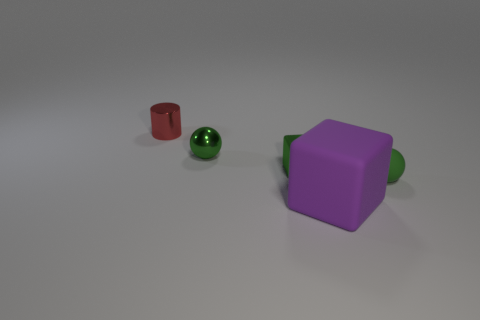Add 5 large purple matte things. How many objects exist? 10 Subtract all cylinders. How many objects are left? 4 Add 2 green metal objects. How many green metal objects are left? 4 Add 1 green spheres. How many green spheres exist? 3 Subtract 0 yellow cubes. How many objects are left? 5 Subtract all small objects. Subtract all brown rubber spheres. How many objects are left? 1 